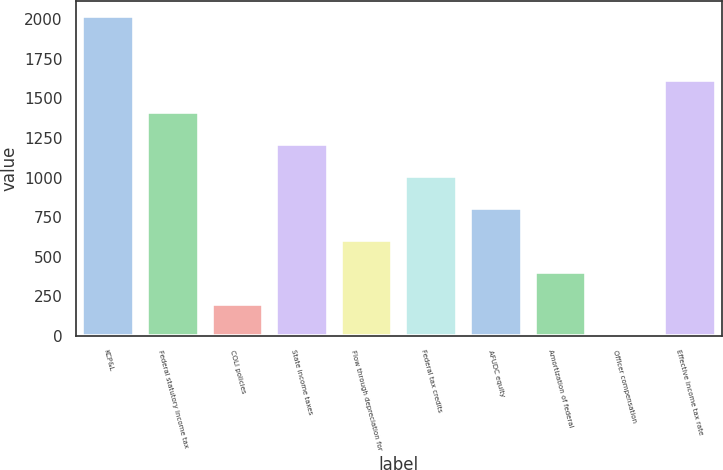Convert chart. <chart><loc_0><loc_0><loc_500><loc_500><bar_chart><fcel>KCP&L<fcel>Federal statutory income tax<fcel>COLI policies<fcel>State income taxes<fcel>Flow through depreciation for<fcel>Federal tax credits<fcel>AFUDC equity<fcel>Amortization of federal<fcel>Officer compensation<fcel>Effective income tax rate<nl><fcel>2017<fcel>1411.93<fcel>201.79<fcel>1210.24<fcel>605.17<fcel>1008.55<fcel>806.86<fcel>403.48<fcel>0.1<fcel>1613.62<nl></chart> 